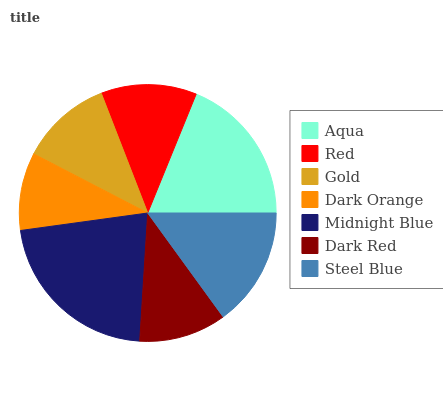Is Dark Orange the minimum?
Answer yes or no. Yes. Is Midnight Blue the maximum?
Answer yes or no. Yes. Is Red the minimum?
Answer yes or no. No. Is Red the maximum?
Answer yes or no. No. Is Aqua greater than Red?
Answer yes or no. Yes. Is Red less than Aqua?
Answer yes or no. Yes. Is Red greater than Aqua?
Answer yes or no. No. Is Aqua less than Red?
Answer yes or no. No. Is Red the high median?
Answer yes or no. Yes. Is Red the low median?
Answer yes or no. Yes. Is Midnight Blue the high median?
Answer yes or no. No. Is Midnight Blue the low median?
Answer yes or no. No. 